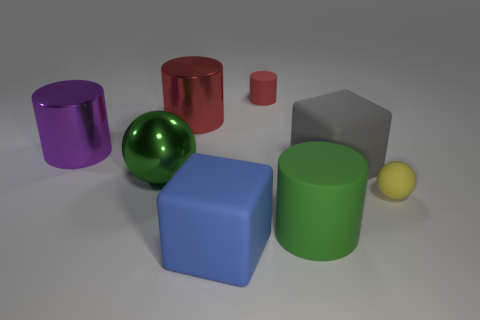There is a green object to the left of the red cylinder that is left of the matte cube in front of the shiny ball; what is its size?
Your response must be concise. Large. What number of other objects are there of the same shape as the yellow object?
Provide a succinct answer. 1. Does the small matte object behind the tiny yellow sphere have the same shape as the large green object that is right of the large red object?
Make the answer very short. Yes. What number of cubes are either tiny red metal things or large objects?
Your answer should be compact. 2. What material is the big gray block in front of the tiny object to the left of the big green thing that is on the right side of the large metallic ball?
Keep it short and to the point. Rubber. What number of other objects are the same size as the purple thing?
Give a very brief answer. 5. The thing that is the same color as the large matte cylinder is what size?
Give a very brief answer. Large. Are there more large green matte cylinders in front of the big gray rubber block than tiny blue metallic things?
Your answer should be very brief. Yes. Is there a cylinder that has the same color as the big shiny ball?
Offer a terse response. Yes. There is a shiny sphere that is the same size as the green rubber object; what color is it?
Offer a very short reply. Green. 